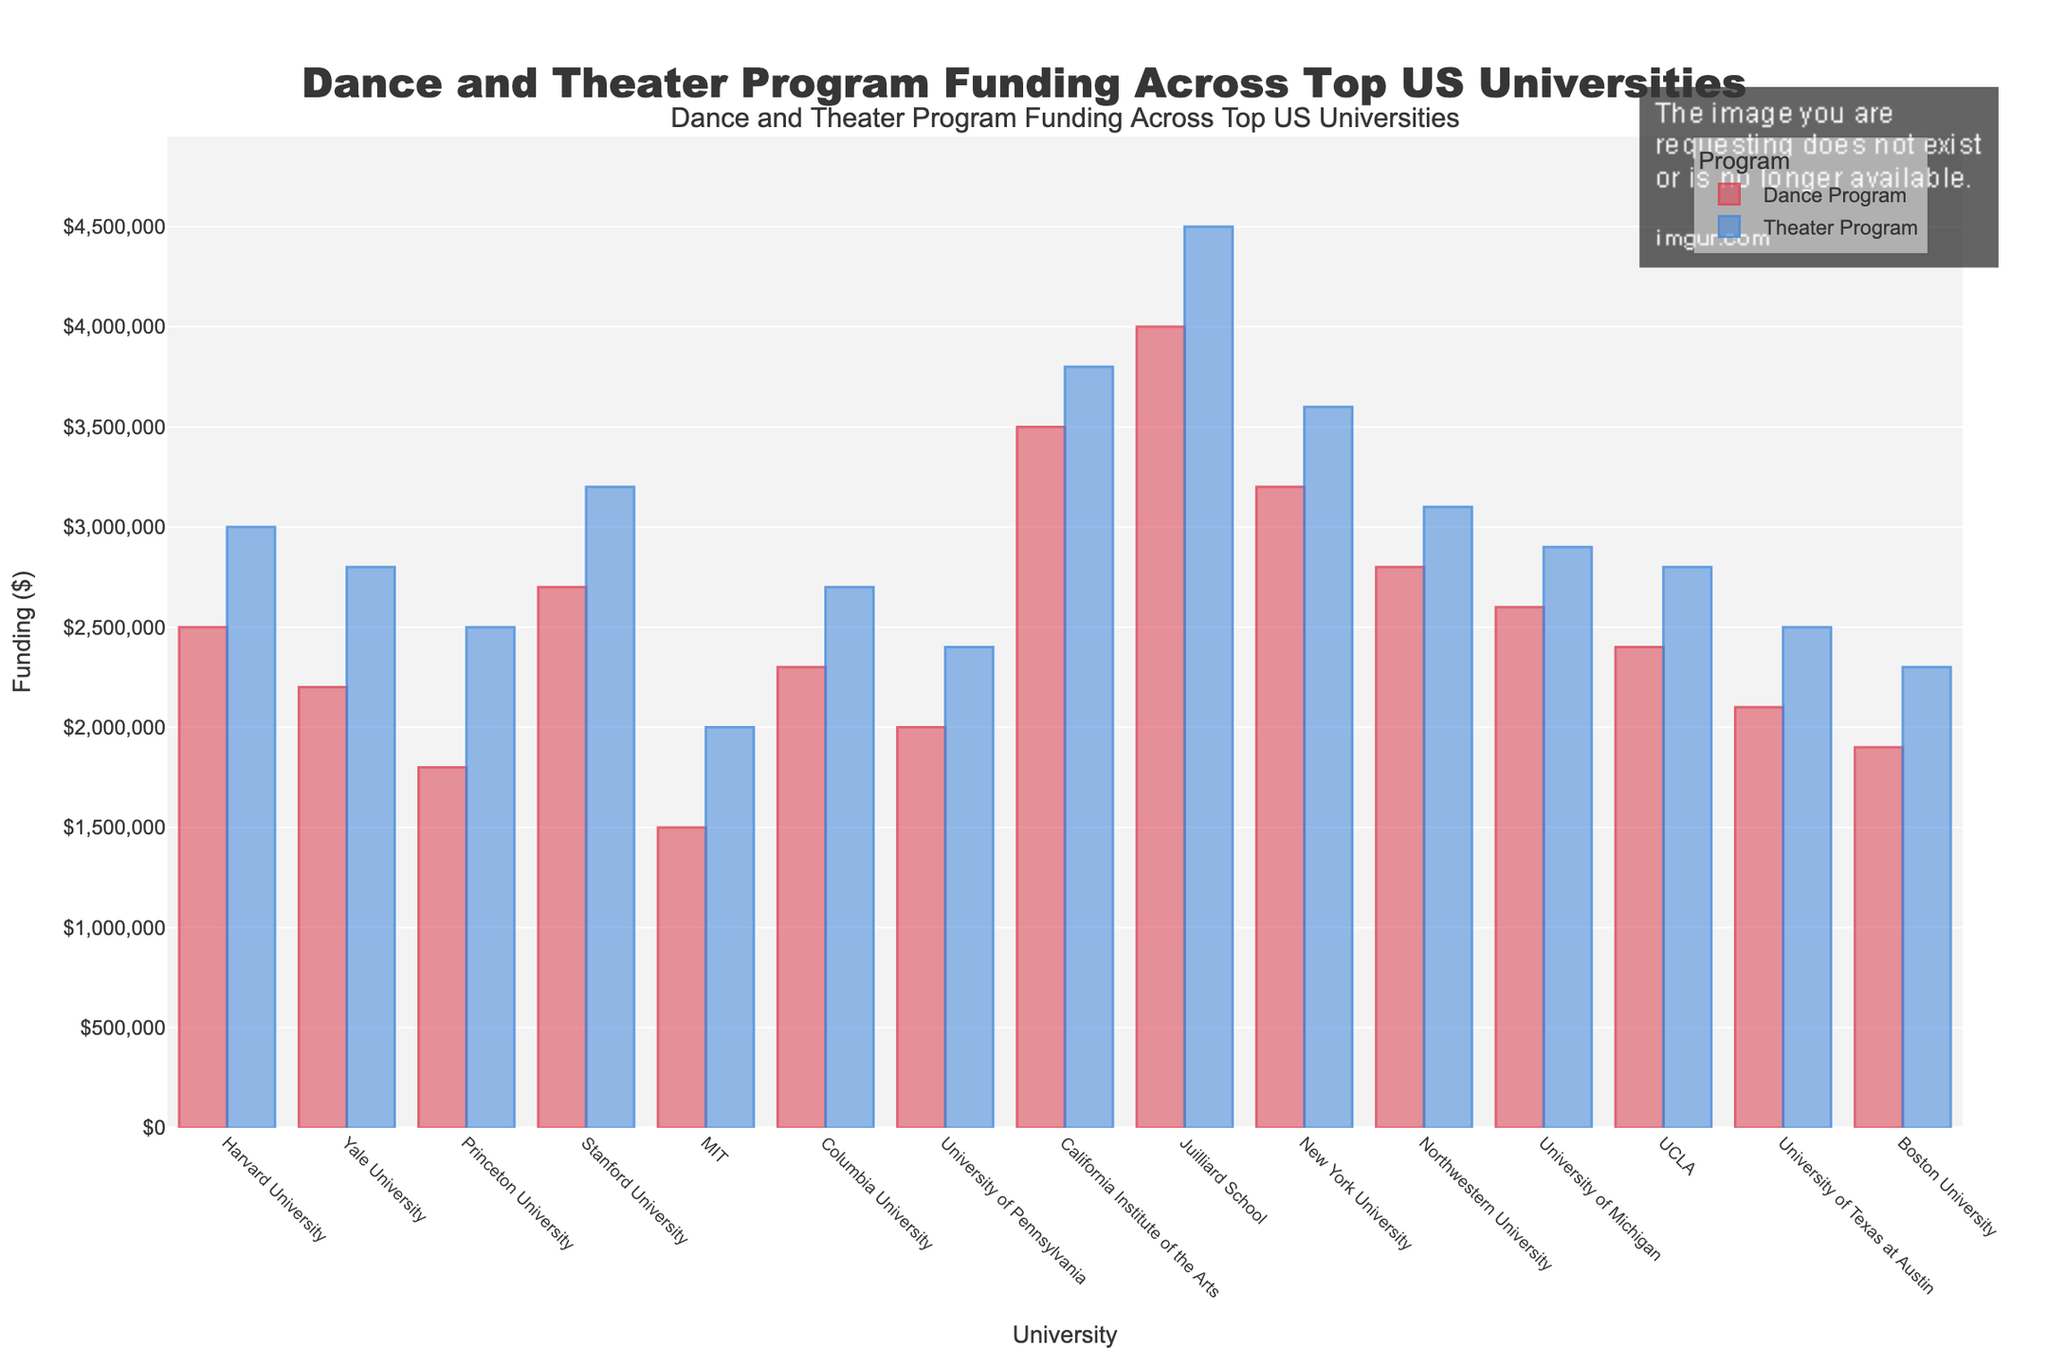Which university has the highest funding for dance programs? Look at the heights of the bars representing dance program funding. The Juilliard School has the tallest bar for dance program funding.
Answer: Juilliard School Which university spends more on theater programs: Harvard or Stanford? Compare the heights of the bars representing theater program funding for Harvard and Stanford. Stanford has a taller bar than Harvard.
Answer: Stanford What is the total funding for both dance and theater programs at the California Institute of the Arts? The dance program is $3,500,000, and the theater program is $3,800,000. Adding these together gives $3,500,000 + $3,800,000 = $7,300,000.
Answer: $7,300,000 Which university has a larger difference between its theater and dance program funding: Yale or UCLA? Yale: $2,800,000 - $2,200,000 = $600,000. UCLA: $2,800,000 - $2,400,000 = $400,000. Yale has a larger difference.
Answer: Yale Which university appears to have the least amount of combined funding for both programs? Compare the heights of the combined bars (dance and theater) for all universities. MIT has the shortest combined bars.
Answer: MIT Which program generally has higher funding across the universities: dance or theater? Observe the heights of all bars for dance and theater programs across all universities. Theater program bars are generally taller.
Answer: Theater What is the average funding for the dance programs across all listed universities? Sum all the dance program funding figures and divide by the number of universities. The sum is $41,000,000. There are 15 universities, so the average is $41,000,000 / 15 ≈ $2,733,333.
Answer: $2,733,333 Which university has the closest funding between its dance and theater programs? Observe the differences between the heights of the dance and theater program bars for each university. Boston University's bars are closest.
Answer: Boston University How many universities allocate more than $3,000,000 to their theater programs? Count the number of universities with theater funding bars exceeding $3,000,000. They are Stanford, California Institute of the Arts, Juilliard School, and New York University. That's 4 universities.
Answer: 4 Which university's theater program receives $500,000 more in funding compared to its dance program? Look for the university where the difference in funding between the theater and dance programs is $500,000. Harvard's theater program ($3,000,000) receives $500,000 more than its dance program ($2,500,000).
Answer: Harvard 